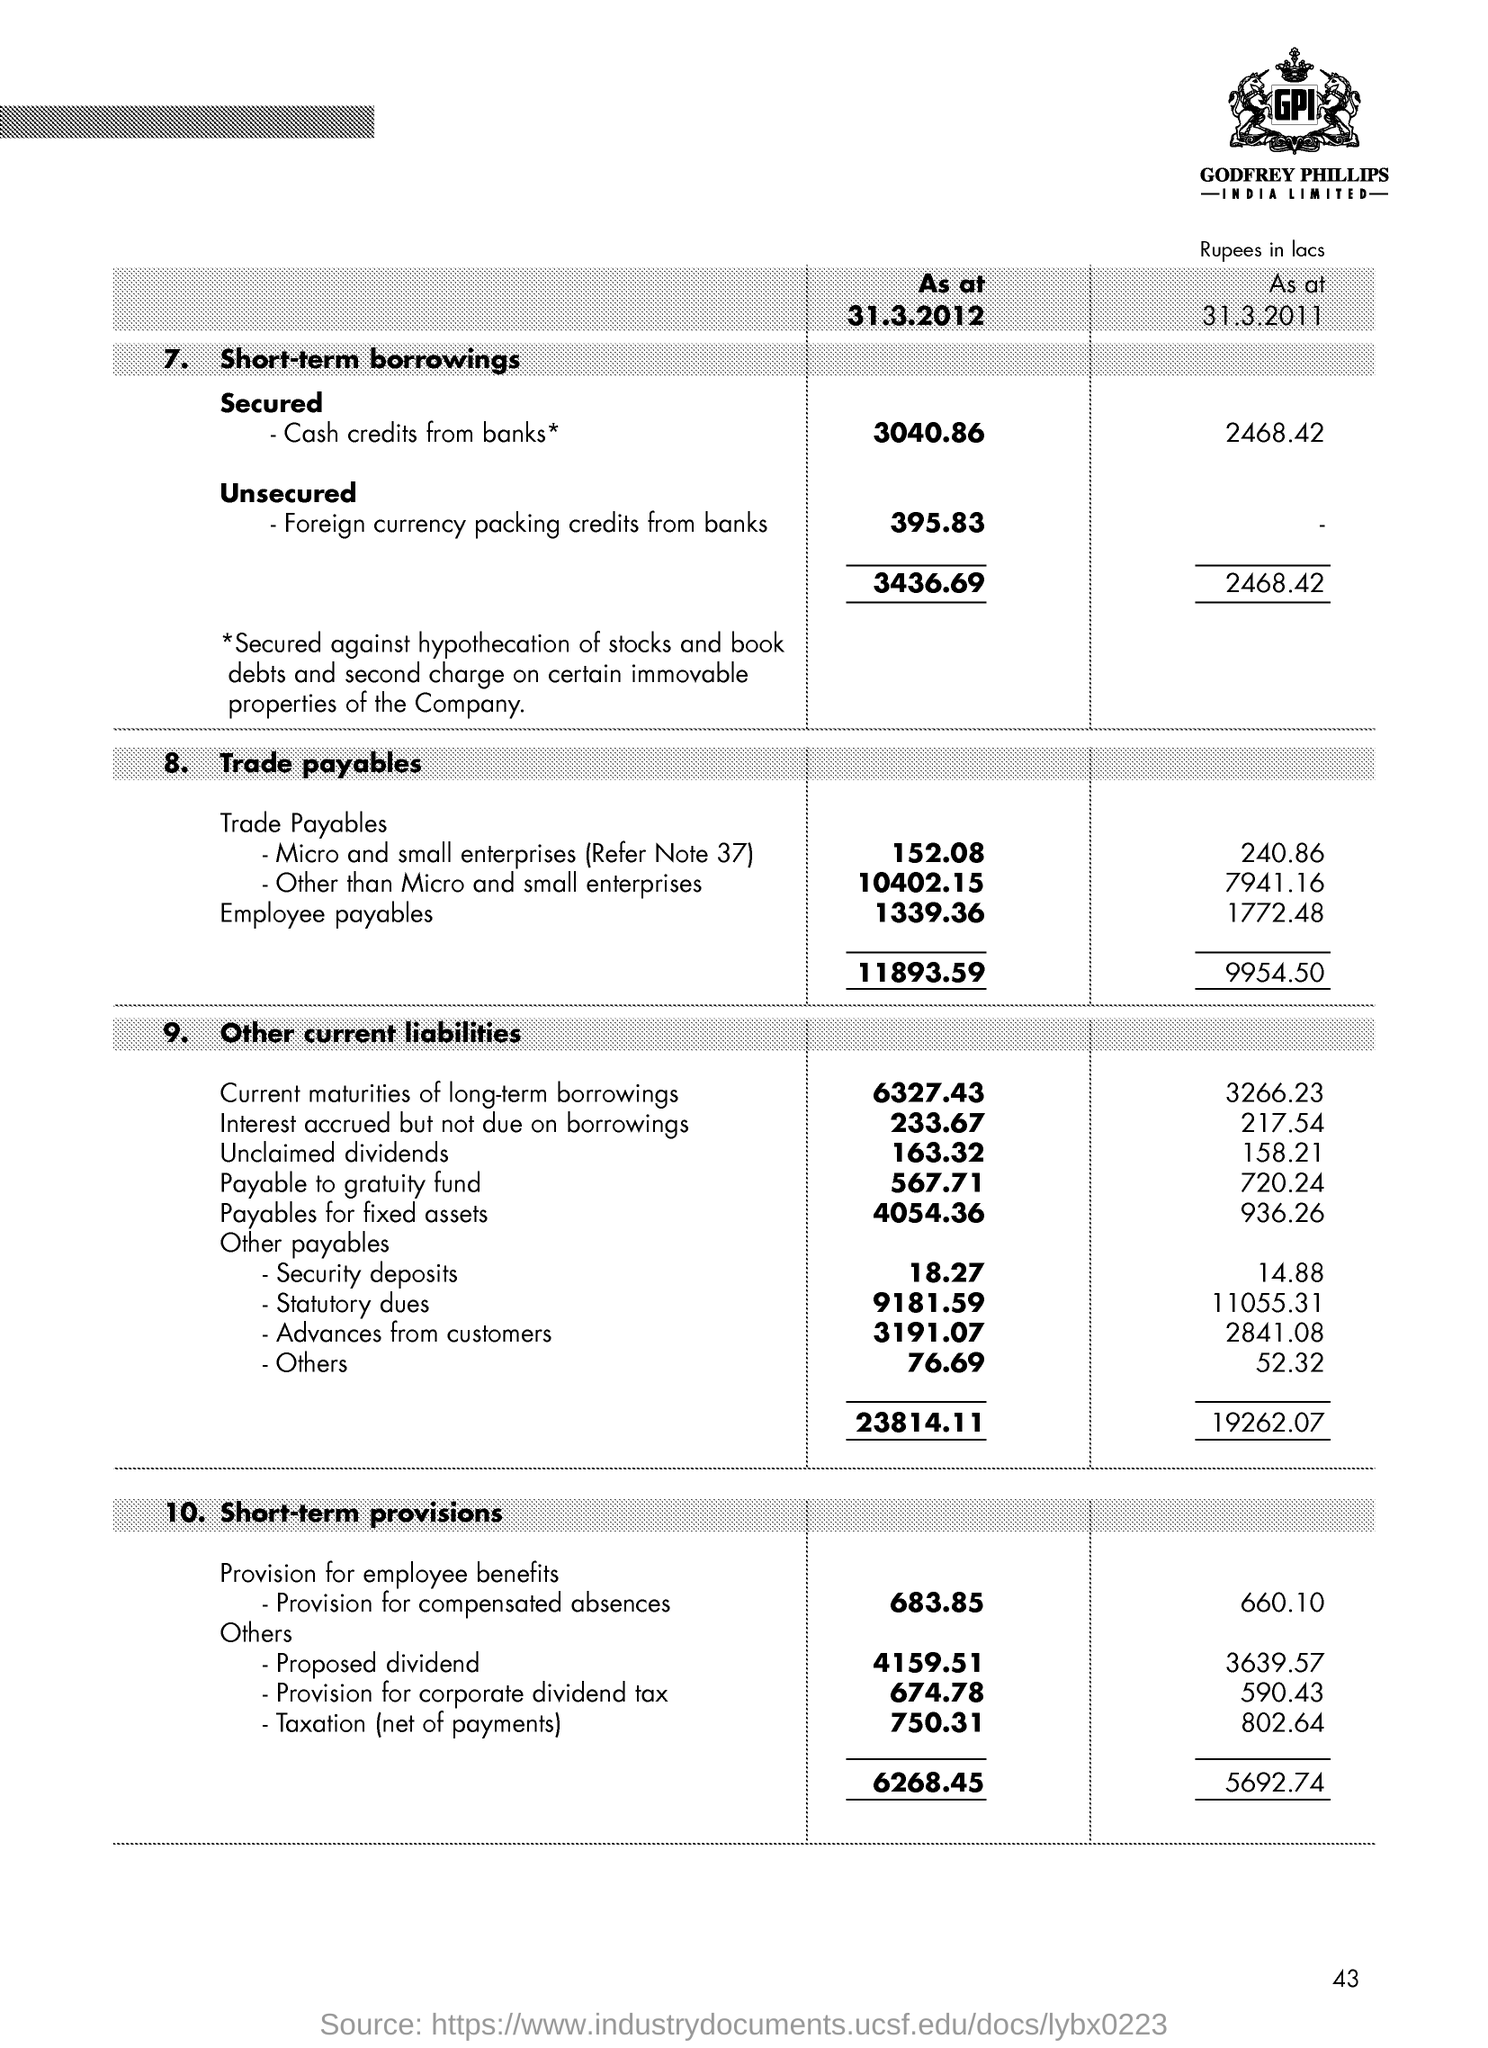What is the name of the company?
Ensure brevity in your answer.  Godfrey Phillips India Limited. Secured cash credit are taken from whom?
Provide a short and direct response. Banks. 